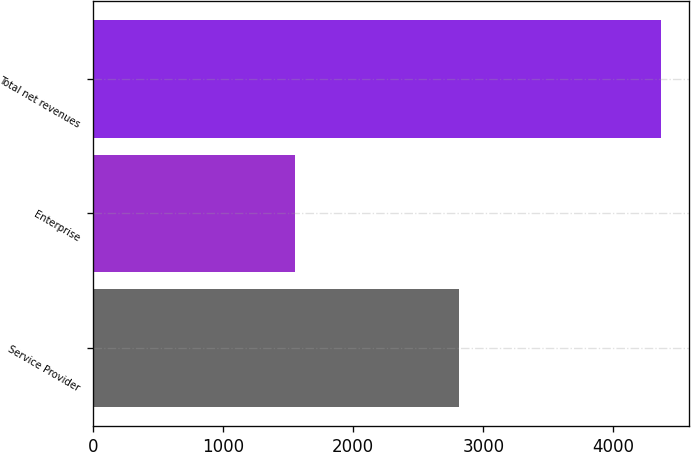Convert chart to OTSL. <chart><loc_0><loc_0><loc_500><loc_500><bar_chart><fcel>Service Provider<fcel>Enterprise<fcel>Total net revenues<nl><fcel>2811.2<fcel>1554.2<fcel>4365.4<nl></chart> 